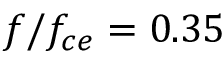<formula> <loc_0><loc_0><loc_500><loc_500>f / f _ { c e } = 0 . 3 5</formula> 